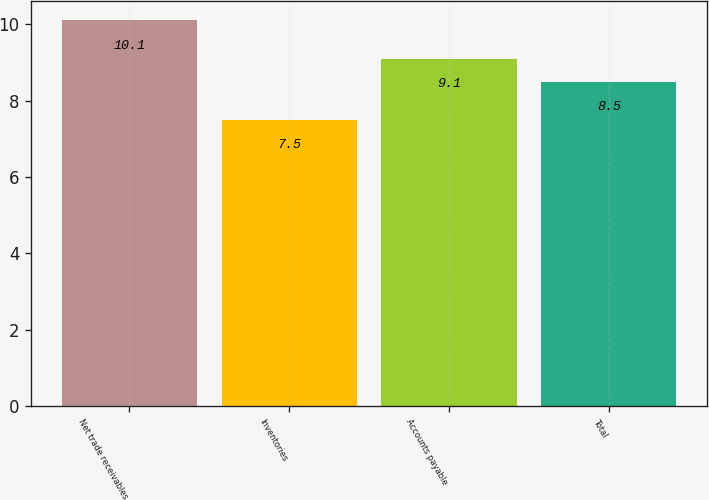Convert chart to OTSL. <chart><loc_0><loc_0><loc_500><loc_500><bar_chart><fcel>Net trade receivables<fcel>Inventories<fcel>Accounts payable<fcel>Total<nl><fcel>10.1<fcel>7.5<fcel>9.1<fcel>8.5<nl></chart> 